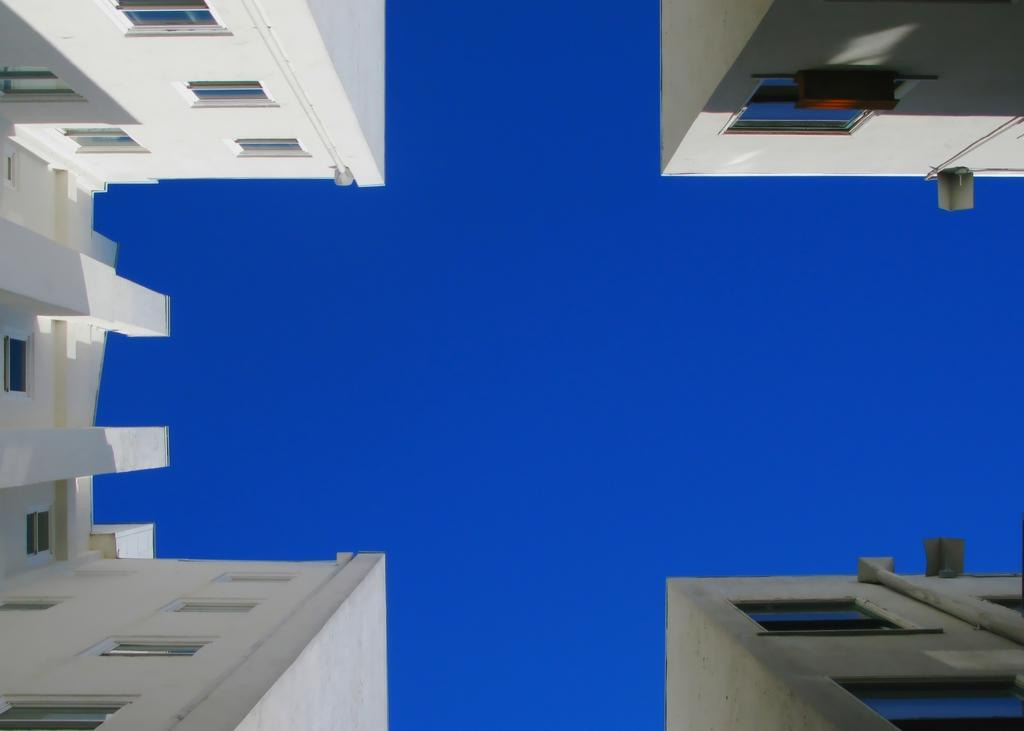What type of view is shown in the image? The image shows a ground view of buildings. What can be seen above the buildings in the image? There is a sky visible in the image. What type of stick is being used to lead the watch in the image? There is no stick, lead, or watch present in the image. 